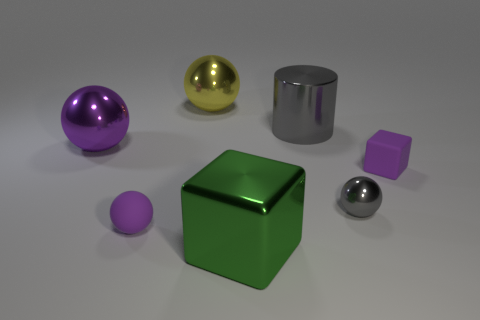Add 1 big yellow balls. How many objects exist? 8 Subtract all gray metal balls. How many balls are left? 3 Subtract all purple balls. How many balls are left? 2 Add 3 shiny things. How many shiny things exist? 8 Subtract 0 brown blocks. How many objects are left? 7 Subtract all blocks. How many objects are left? 5 Subtract 1 cylinders. How many cylinders are left? 0 Subtract all cyan blocks. Subtract all yellow spheres. How many blocks are left? 2 Subtract all red blocks. How many cyan cylinders are left? 0 Subtract all big red matte cylinders. Subtract all large yellow spheres. How many objects are left? 6 